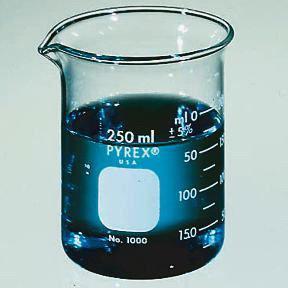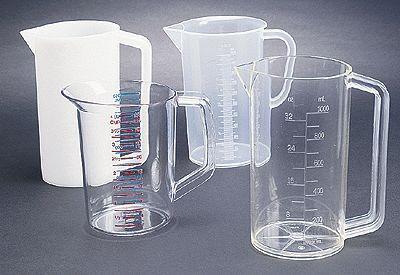The first image is the image on the left, the second image is the image on the right. Examine the images to the left and right. Is the description "blu liquid is in the beaker" accurate? Answer yes or no. Yes. The first image is the image on the left, the second image is the image on the right. Analyze the images presented: Is the assertion "There is no less than one clear beaker filled with a blue liquid" valid? Answer yes or no. Yes. 